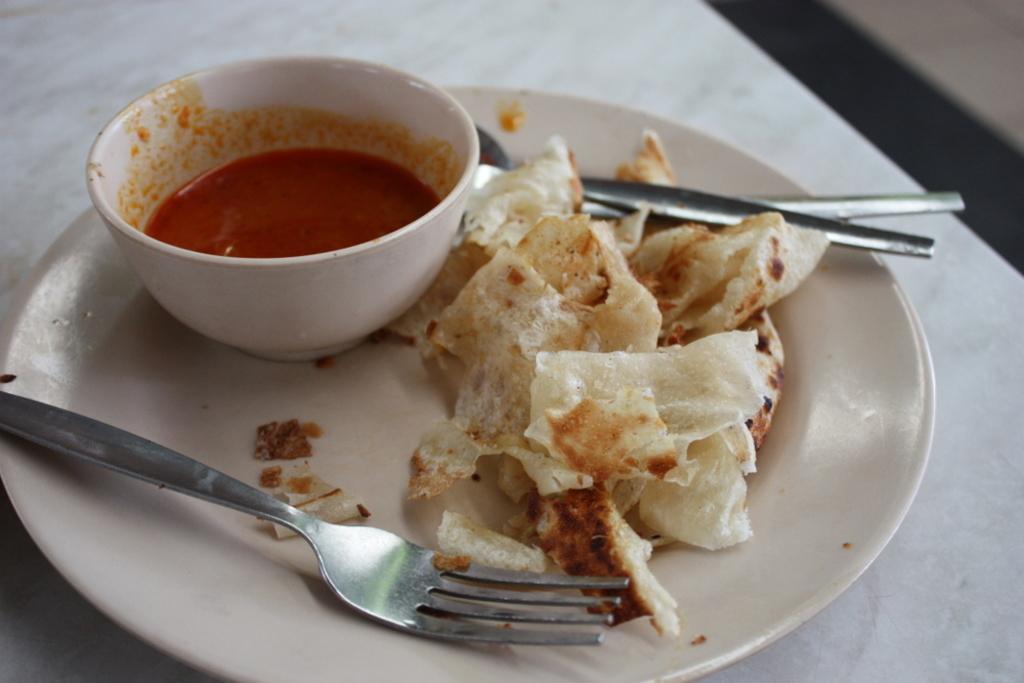Describe this image in one or two sentences. These are the food items in a white color plate, there is a bowl, on the left side it is the stainless steel fork. 